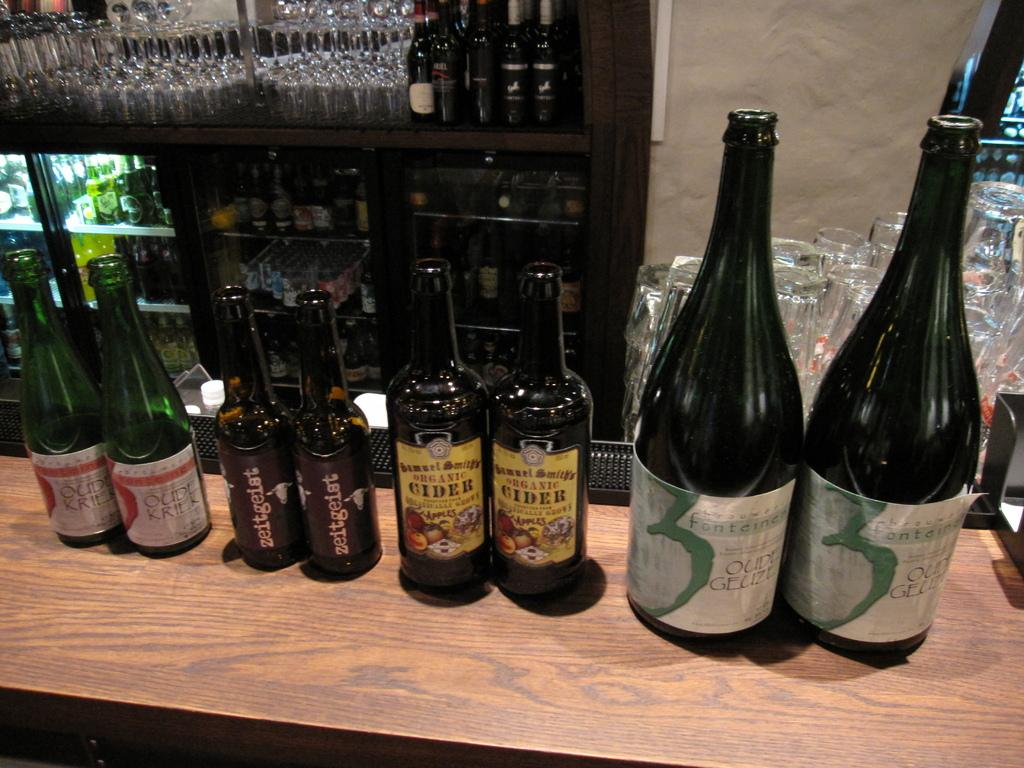Provide a one-sentence caption for the provided image. 2 bottles each of oudl kriek, zeitgeist, organic cider, and oudl gelize. 